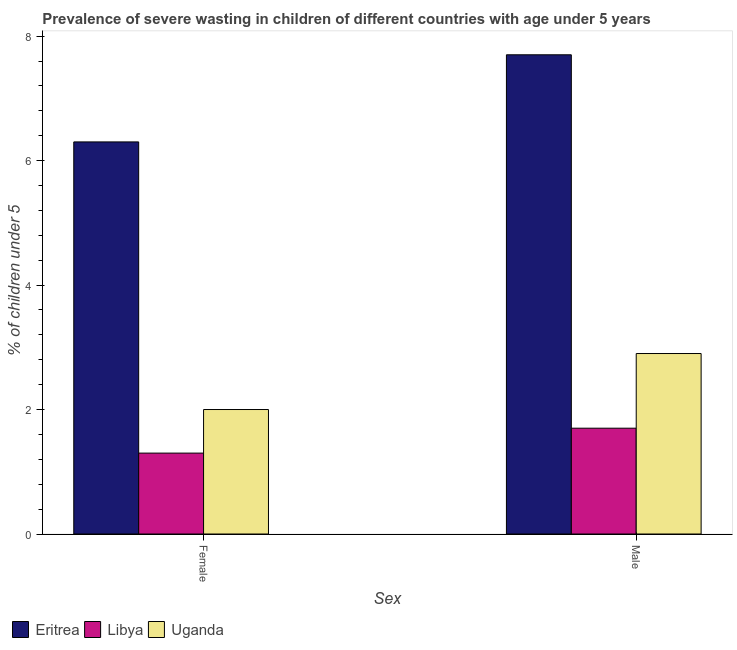How many different coloured bars are there?
Provide a succinct answer. 3. How many groups of bars are there?
Provide a succinct answer. 2. Are the number of bars per tick equal to the number of legend labels?
Provide a short and direct response. Yes. Are the number of bars on each tick of the X-axis equal?
Your response must be concise. Yes. How many bars are there on the 2nd tick from the left?
Your response must be concise. 3. How many bars are there on the 2nd tick from the right?
Offer a terse response. 3. What is the percentage of undernourished male children in Eritrea?
Keep it short and to the point. 7.7. Across all countries, what is the maximum percentage of undernourished male children?
Offer a terse response. 7.7. Across all countries, what is the minimum percentage of undernourished female children?
Your response must be concise. 1.3. In which country was the percentage of undernourished female children maximum?
Your response must be concise. Eritrea. In which country was the percentage of undernourished male children minimum?
Give a very brief answer. Libya. What is the total percentage of undernourished female children in the graph?
Offer a very short reply. 9.6. What is the difference between the percentage of undernourished female children in Eritrea and that in Libya?
Ensure brevity in your answer.  5. What is the difference between the percentage of undernourished male children in Eritrea and the percentage of undernourished female children in Uganda?
Provide a short and direct response. 5.7. What is the average percentage of undernourished female children per country?
Offer a terse response. 3.2. What is the difference between the percentage of undernourished male children and percentage of undernourished female children in Libya?
Your answer should be compact. 0.4. In how many countries, is the percentage of undernourished female children greater than 5.6 %?
Provide a short and direct response. 1. What is the ratio of the percentage of undernourished male children in Eritrea to that in Libya?
Give a very brief answer. 4.53. What does the 3rd bar from the left in Female represents?
Your response must be concise. Uganda. What does the 3rd bar from the right in Female represents?
Make the answer very short. Eritrea. How many bars are there?
Your answer should be very brief. 6. What is the title of the graph?
Make the answer very short. Prevalence of severe wasting in children of different countries with age under 5 years. What is the label or title of the X-axis?
Your answer should be compact. Sex. What is the label or title of the Y-axis?
Your answer should be very brief.  % of children under 5. What is the  % of children under 5 in Eritrea in Female?
Offer a terse response. 6.3. What is the  % of children under 5 in Libya in Female?
Provide a short and direct response. 1.3. What is the  % of children under 5 of Uganda in Female?
Keep it short and to the point. 2. What is the  % of children under 5 in Eritrea in Male?
Provide a succinct answer. 7.7. What is the  % of children under 5 in Libya in Male?
Your response must be concise. 1.7. What is the  % of children under 5 of Uganda in Male?
Make the answer very short. 2.9. Across all Sex, what is the maximum  % of children under 5 in Eritrea?
Provide a succinct answer. 7.7. Across all Sex, what is the maximum  % of children under 5 in Libya?
Make the answer very short. 1.7. Across all Sex, what is the maximum  % of children under 5 in Uganda?
Make the answer very short. 2.9. Across all Sex, what is the minimum  % of children under 5 of Eritrea?
Offer a very short reply. 6.3. Across all Sex, what is the minimum  % of children under 5 of Libya?
Your answer should be very brief. 1.3. What is the total  % of children under 5 of Uganda in the graph?
Your answer should be very brief. 4.9. What is the difference between the  % of children under 5 in Uganda in Female and that in Male?
Offer a terse response. -0.9. What is the difference between the  % of children under 5 in Eritrea in Female and the  % of children under 5 in Uganda in Male?
Offer a terse response. 3.4. What is the average  % of children under 5 of Eritrea per Sex?
Give a very brief answer. 7. What is the average  % of children under 5 of Libya per Sex?
Offer a terse response. 1.5. What is the average  % of children under 5 of Uganda per Sex?
Your response must be concise. 2.45. What is the difference between the  % of children under 5 in Eritrea and  % of children under 5 in Uganda in Male?
Your answer should be very brief. 4.8. What is the ratio of the  % of children under 5 in Eritrea in Female to that in Male?
Keep it short and to the point. 0.82. What is the ratio of the  % of children under 5 of Libya in Female to that in Male?
Give a very brief answer. 0.76. What is the ratio of the  % of children under 5 in Uganda in Female to that in Male?
Your response must be concise. 0.69. What is the difference between the highest and the second highest  % of children under 5 in Eritrea?
Keep it short and to the point. 1.4. What is the difference between the highest and the second highest  % of children under 5 in Uganda?
Keep it short and to the point. 0.9. What is the difference between the highest and the lowest  % of children under 5 in Eritrea?
Your answer should be very brief. 1.4. What is the difference between the highest and the lowest  % of children under 5 in Uganda?
Provide a short and direct response. 0.9. 